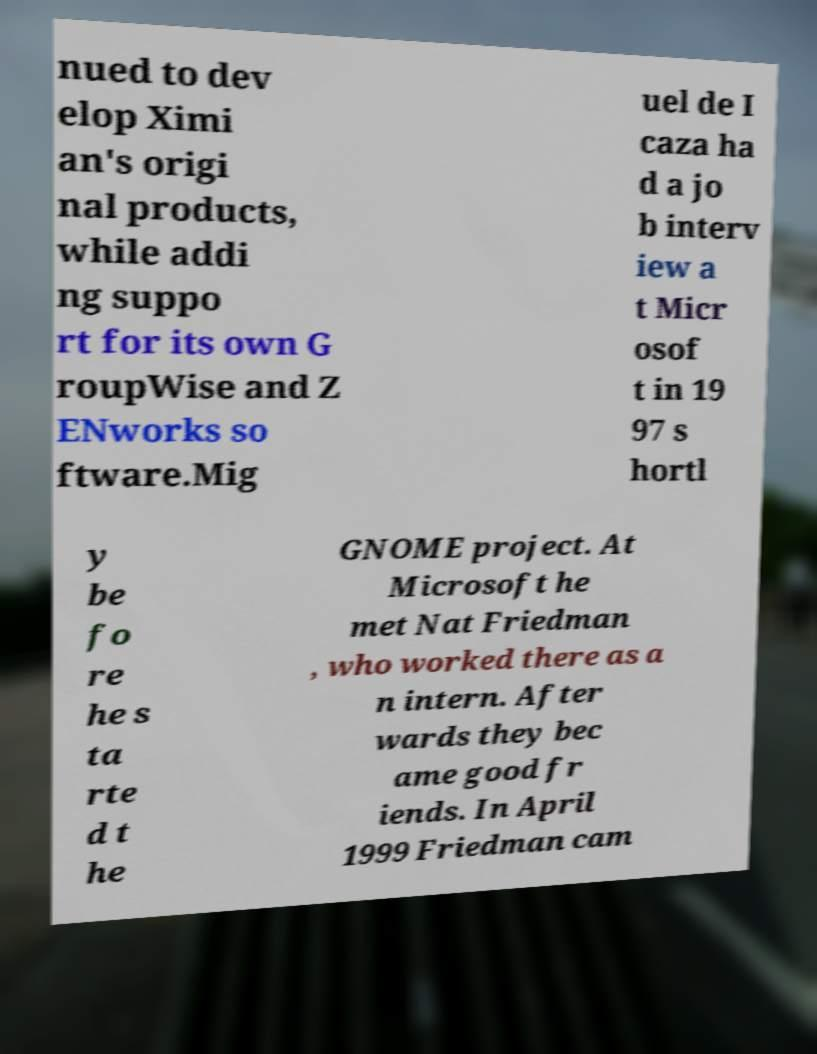There's text embedded in this image that I need extracted. Can you transcribe it verbatim? nued to dev elop Ximi an's origi nal products, while addi ng suppo rt for its own G roupWise and Z ENworks so ftware.Mig uel de I caza ha d a jo b interv iew a t Micr osof t in 19 97 s hortl y be fo re he s ta rte d t he GNOME project. At Microsoft he met Nat Friedman , who worked there as a n intern. After wards they bec ame good fr iends. In April 1999 Friedman cam 